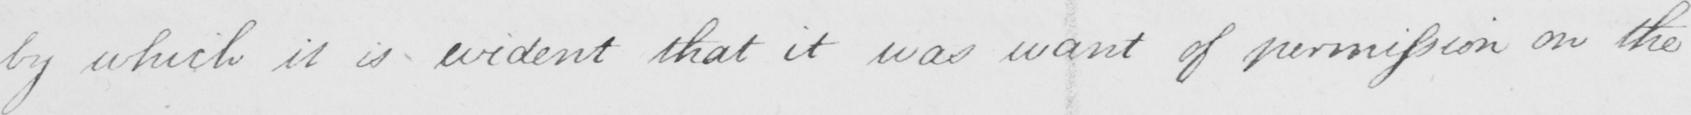What does this handwritten line say? by which it is evident that it was want of permission on the 